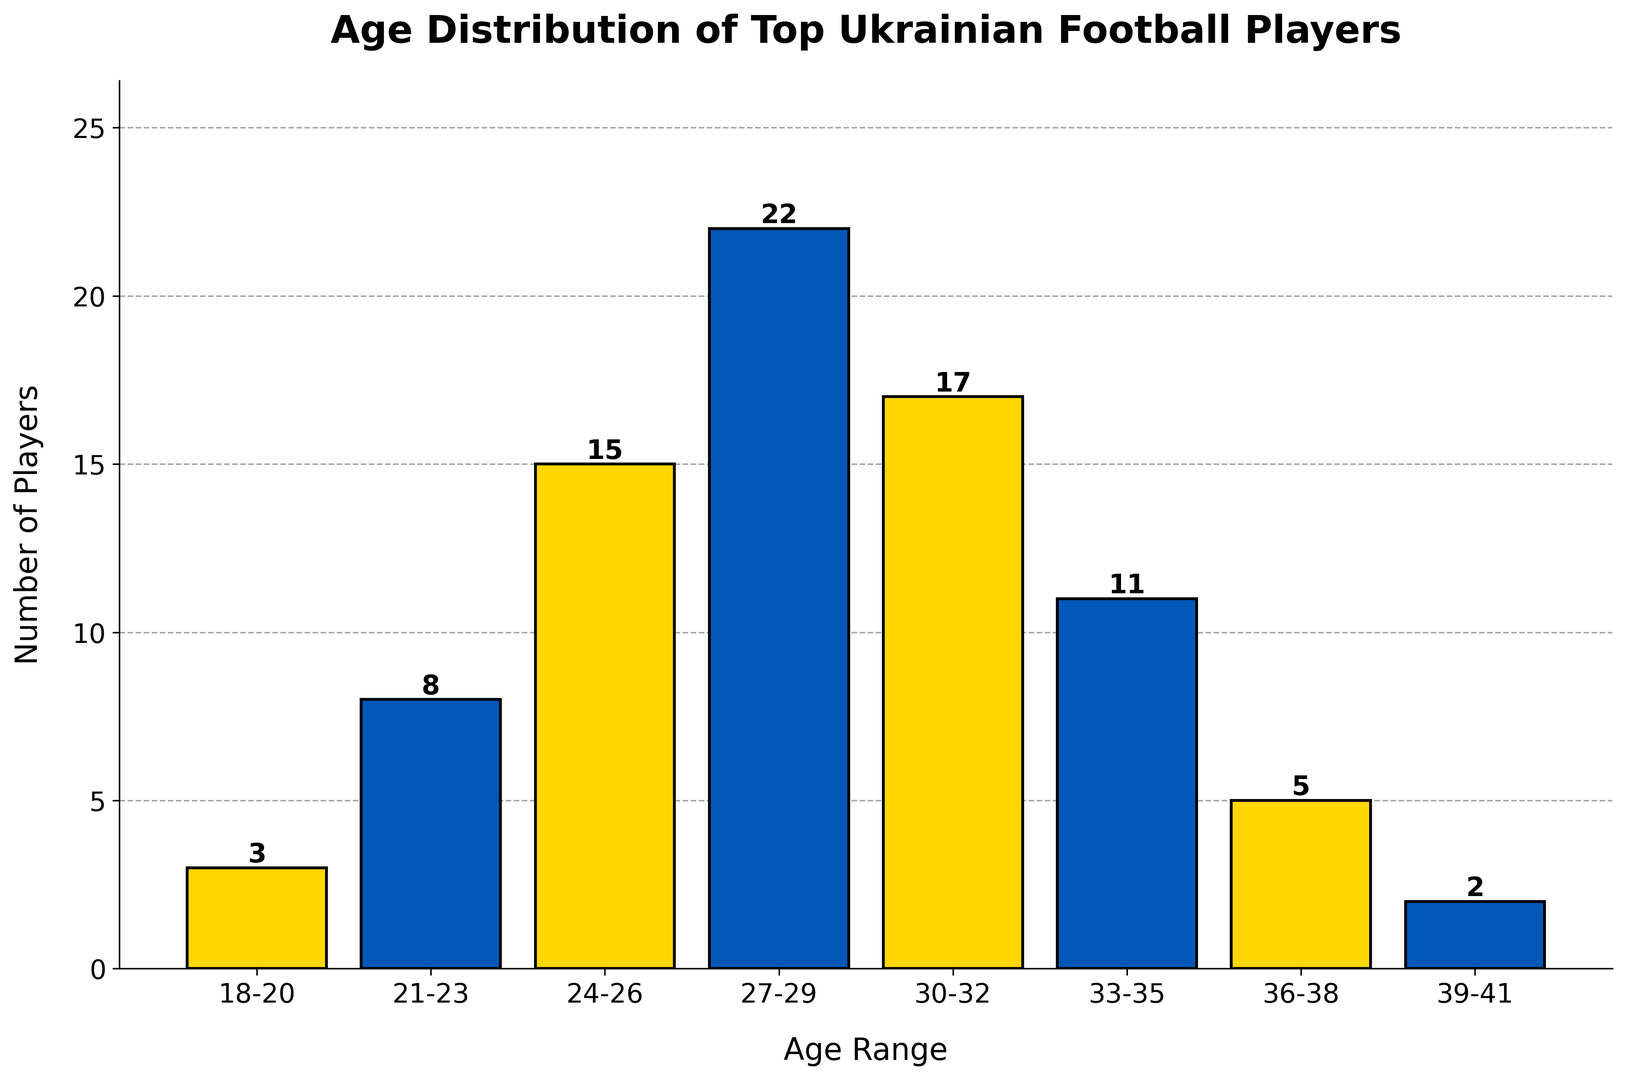What's the most common age range for top-performing Ukrainian football players? The tallest bar in the histogram represents the age range with the highest count. Here, the tallest bar corresponds to the 27-29 age range.
Answer: 27-29 How many more players are there in the 27-29 range compared to the 18-20 range? There are 22 players in the 27-29 range and 3 players in the 18-20 range. Subtracting the latter from the former gives 22 - 3 = 19.
Answer: 19 In which age range is the number of top-performing players closest to 12? To find this, we visually compare each bar’s height to the value 12. The 33-35 age range, with a count of 11, is the closest.
Answer: 33-35 What's the total number of players in the age ranges 24-26 and 30-32 combined? Summing the counts for the 24-26 range (15) and the 30-32 range (17) gives 15 + 17 = 32.
Answer: 32 How does the number of players in the 36-38 range compare to those in the 21-23 range? The 36-38 range has 5 players, while the 21-23 range has 8 players. There are 3 fewer players in the 36-38 range than in the 21-23 range.
Answer: 3 fewer Which age range has a bar colored differently than the 21-23 range? The 21-23 range is colored blue. The adjacent age ranges 18-20 and 24-26 are colored yellow.
Answer: 18-20 or 24-26 What is the total number of players depicted in the histogram? Sum the counts of all age ranges: 3 + 8 + 15 + 22 + 17 + 11 + 5 + 2 = 83.
Answer: 83 Are there more players in the 33-35 range than in the 36-38 range? The count for the 33-35 range is 11, while it is 5 for the 36-38 range. Yes, there are more players in the 33-35 range.
Answer: Yes Which age range has the least number of players? The shortest bar on the histogram represents the 39-41 age range, with a count of 2.
Answer: 39-41 